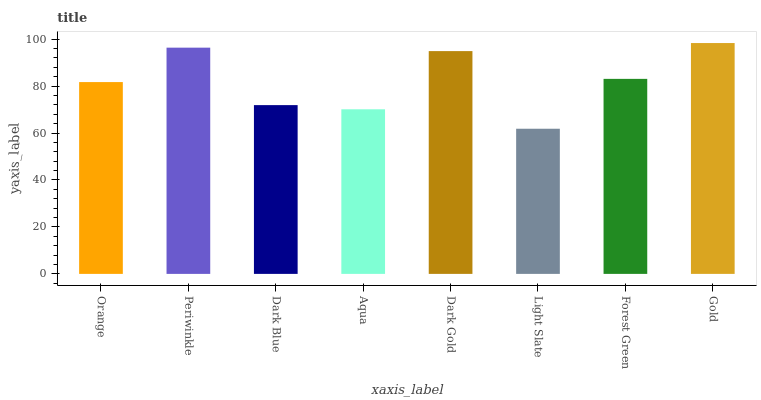Is Light Slate the minimum?
Answer yes or no. Yes. Is Gold the maximum?
Answer yes or no. Yes. Is Periwinkle the minimum?
Answer yes or no. No. Is Periwinkle the maximum?
Answer yes or no. No. Is Periwinkle greater than Orange?
Answer yes or no. Yes. Is Orange less than Periwinkle?
Answer yes or no. Yes. Is Orange greater than Periwinkle?
Answer yes or no. No. Is Periwinkle less than Orange?
Answer yes or no. No. Is Forest Green the high median?
Answer yes or no. Yes. Is Orange the low median?
Answer yes or no. Yes. Is Gold the high median?
Answer yes or no. No. Is Aqua the low median?
Answer yes or no. No. 